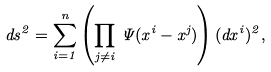Convert formula to latex. <formula><loc_0><loc_0><loc_500><loc_500>d s ^ { 2 } = \sum _ { i = 1 } ^ { n } \left ( \prod _ { j \ne i } \, \Psi ( x ^ { i } - x ^ { j } ) \right ) ( d x ^ { i } ) ^ { 2 } ,</formula> 